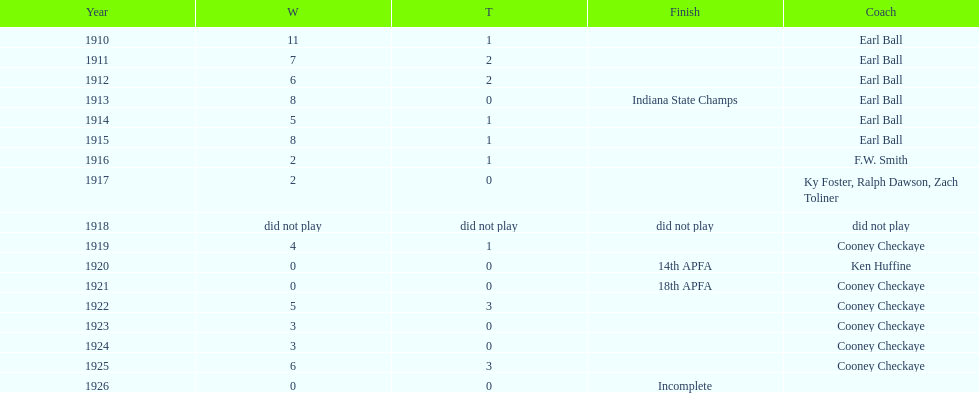In what year did the muncie flyers have an undefeated record? 1910. 